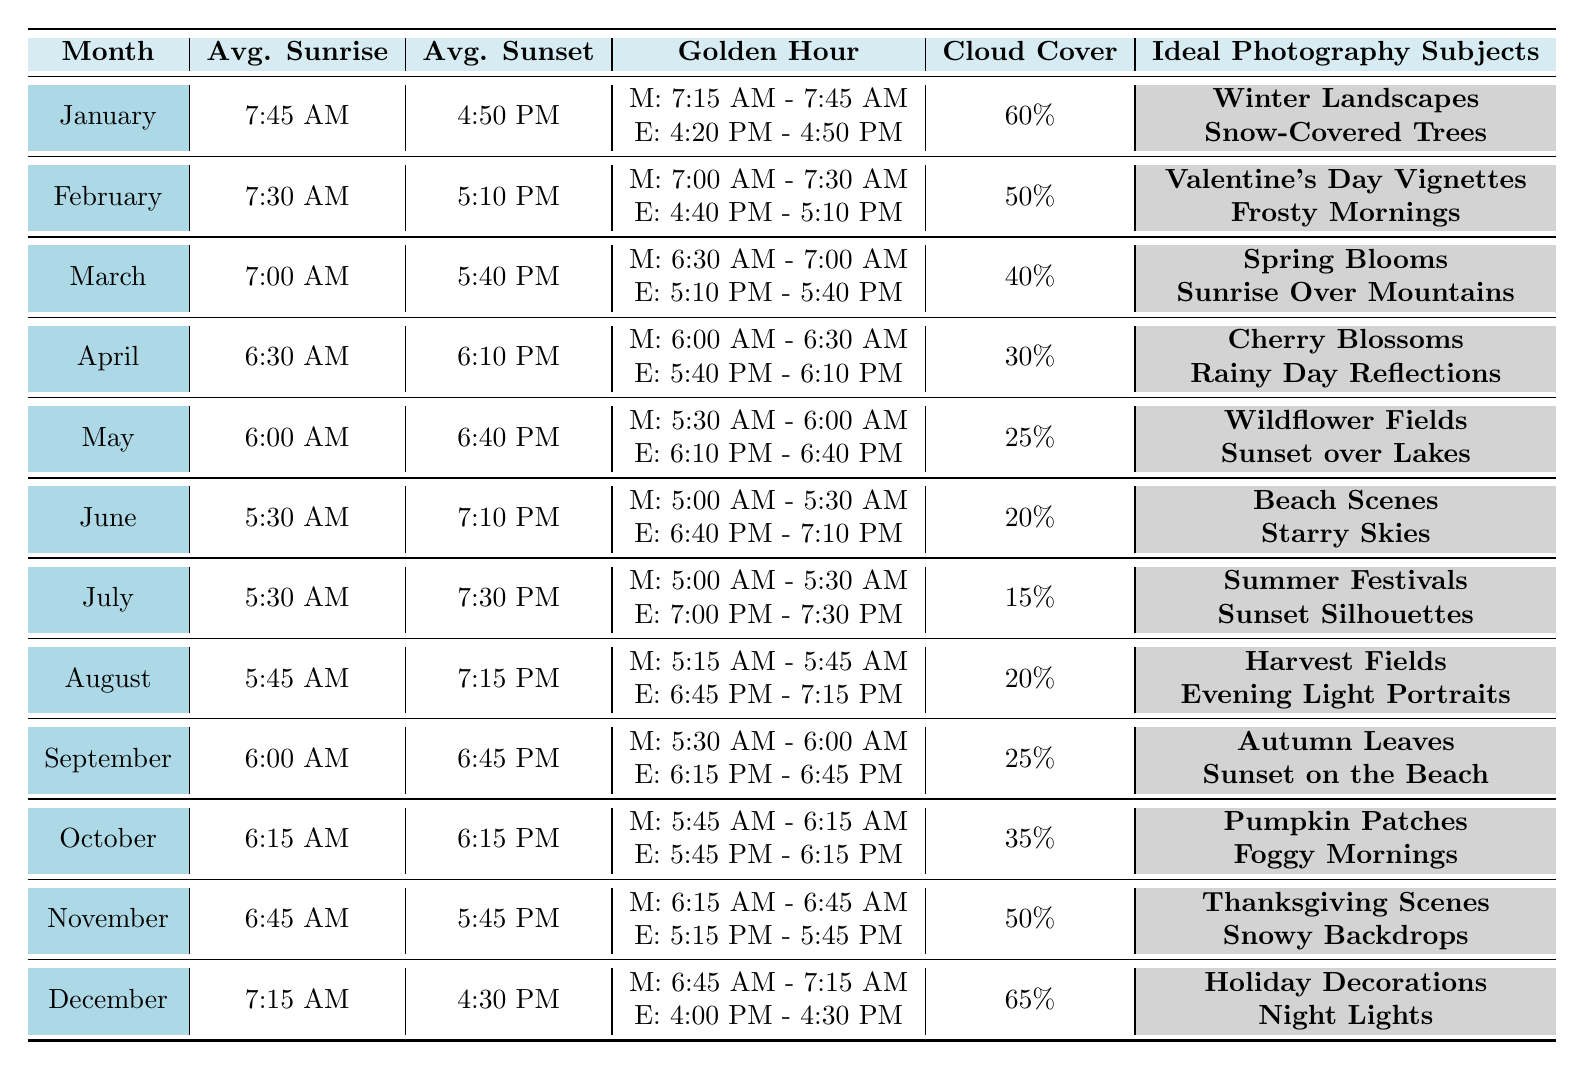What is the average sunrise time in June? The average sunrise time in June is listed in the table as 5:30 AM.
Answer: 5:30 AM Which month has the earliest average sunset? I look at the average sunset times and see that December has the latest sunset at 4:30 PM, while the earliest average sunset is in January at 4:50 PM.
Answer: January How many months have a cloud cover percentage below 30%? I check the cloud cover percentages: June (20%), July (15%), and August (20%) all are below 30%. That's a total of 3 months.
Answer: 3 What is the difference in average sunset times between August and February? The average sunset time in August is 7:15 PM, and in February it is 5:10 PM. Converting them to 24-hour format gives 19:15 and 17:10 respectively. The difference is 19:15 - 17:10 = 2 hours and 5 minutes.
Answer: 2 hours and 5 minutes In which month is the golden hour in the morning the longest? The golden hour in the morning is 30 minutes long in July (5:00 AM - 5:30 AM) and the rest of the months have golden hours shorter than that. Hence, July has the longest morning golden hour.
Answer: July Which ideal photography subjects are found in the month of March? Reviewing the ideal photography subjects for March, they are Spring Blooms and Sunrise Over Mountains.
Answer: Spring Blooms, Sunrise Over Mountains Is the cloud cover in November higher than in December? In November, the cloud cover is 50% and in December, it is 65%, indicating that December has a higher cloud cover than November.
Answer: No By what percentage does cloud cover decrease from April to May? April has a cloud cover percentage of 30%, while May shows 25%. The decrease is 30% - 25% = 5%. To find the percentage decrease relative to April, I calculate (5% / 30%) * 100% = 16.67%.
Answer: 16.67% In which month is the golden hour in the evening the latest? The latest evening golden hour is in June, lasting until 7:10 PM, while in the other months, it finishes earlier.
Answer: June What are the ideal photography subjects for the month of October? Looking at the entries for October, the ideal photography subjects are Pumpkin Patches and Foggy Mornings.
Answer: Pumpkin Patches, Foggy Mornings 